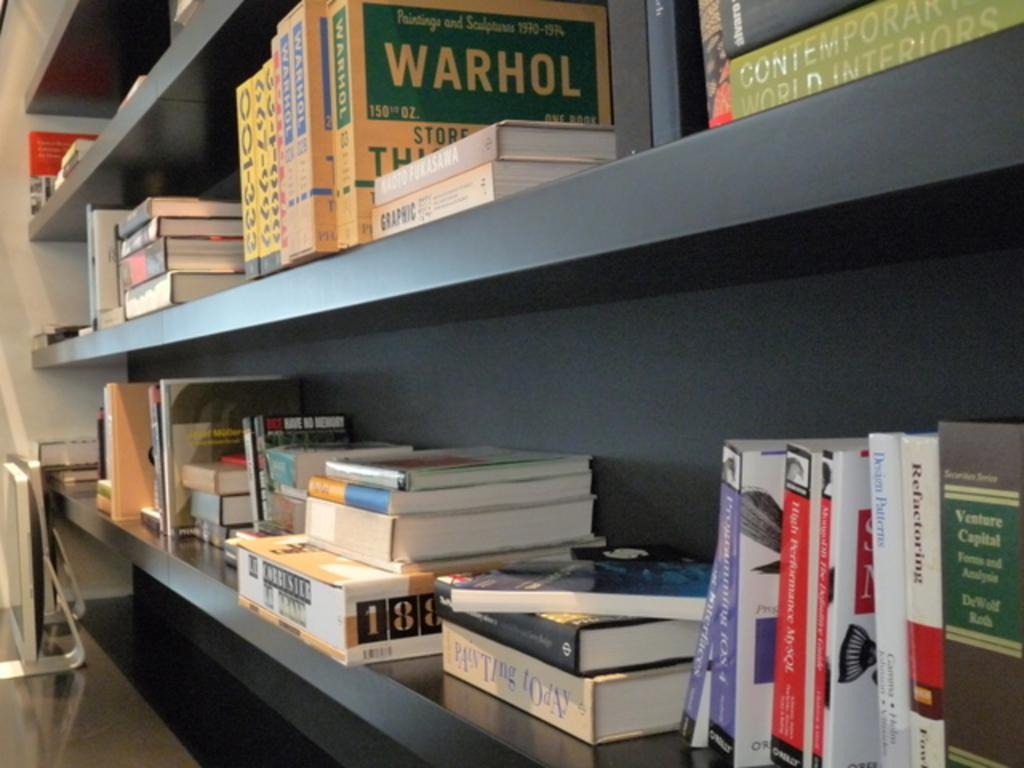Provide a one-sentence caption for the provided image. Books and materials on a classroom shelf include information about Warhol and titles such as Contemporary World Interiors and Painting Today. 